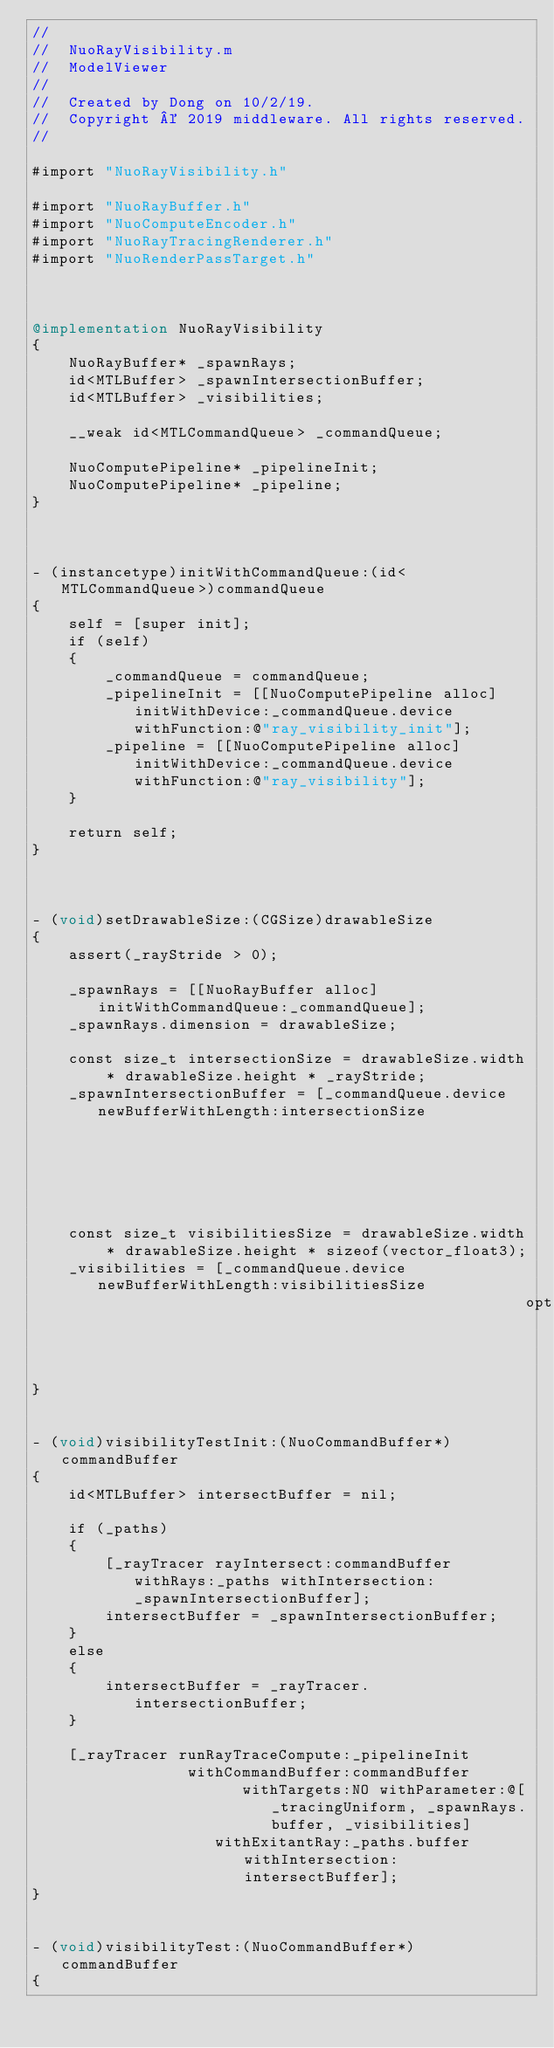Convert code to text. <code><loc_0><loc_0><loc_500><loc_500><_ObjectiveC_>//
//  NuoRayVisibility.m
//  ModelViewer
//
//  Created by Dong on 10/2/19.
//  Copyright © 2019 middleware. All rights reserved.
//

#import "NuoRayVisibility.h"

#import "NuoRayBuffer.h"
#import "NuoComputeEncoder.h"
#import "NuoRayTracingRenderer.h"
#import "NuoRenderPassTarget.h"



@implementation NuoRayVisibility
{
    NuoRayBuffer* _spawnRays;
    id<MTLBuffer> _spawnIntersectionBuffer;
    id<MTLBuffer> _visibilities;
    
    __weak id<MTLCommandQueue> _commandQueue;
    
    NuoComputePipeline* _pipelineInit;
    NuoComputePipeline* _pipeline;
}



- (instancetype)initWithCommandQueue:(id<MTLCommandQueue>)commandQueue
{
    self = [super init];
    if (self)
    {
        _commandQueue = commandQueue;
        _pipelineInit = [[NuoComputePipeline alloc] initWithDevice:_commandQueue.device withFunction:@"ray_visibility_init"];
        _pipeline = [[NuoComputePipeline alloc] initWithDevice:_commandQueue.device withFunction:@"ray_visibility"];
    }
    
    return self;
}



- (void)setDrawableSize:(CGSize)drawableSize
{
    assert(_rayStride > 0);
    
    _spawnRays = [[NuoRayBuffer alloc] initWithCommandQueue:_commandQueue];
    _spawnRays.dimension = drawableSize;
    
    const size_t intersectionSize = drawableSize.width * drawableSize.height * _rayStride;
    _spawnIntersectionBuffer = [_commandQueue.device newBufferWithLength:intersectionSize
                                                                 options:MTLResourceStorageModePrivate];
    
    const size_t visibilitiesSize = drawableSize.width * drawableSize.height * sizeof(vector_float3);
    _visibilities = [_commandQueue.device newBufferWithLength:visibilitiesSize
                                                      options:MTLResourceStorageModePrivate];
}


- (void)visibilityTestInit:(NuoCommandBuffer*)commandBuffer
{
    id<MTLBuffer> intersectBuffer = nil;
    
    if (_paths)
    {
        [_rayTracer rayIntersect:commandBuffer withRays:_paths withIntersection:_spawnIntersectionBuffer];
        intersectBuffer = _spawnIntersectionBuffer;
    }
    else
    {
        intersectBuffer = _rayTracer.intersectionBuffer;
    }
    
    [_rayTracer runRayTraceCompute:_pipelineInit
                 withCommandBuffer:commandBuffer
                       withTargets:NO withParameter:@[_tracingUniform, _spawnRays.buffer, _visibilities]
                    withExitantRay:_paths.buffer withIntersection:intersectBuffer];
}


- (void)visibilityTest:(NuoCommandBuffer*)commandBuffer
{</code> 